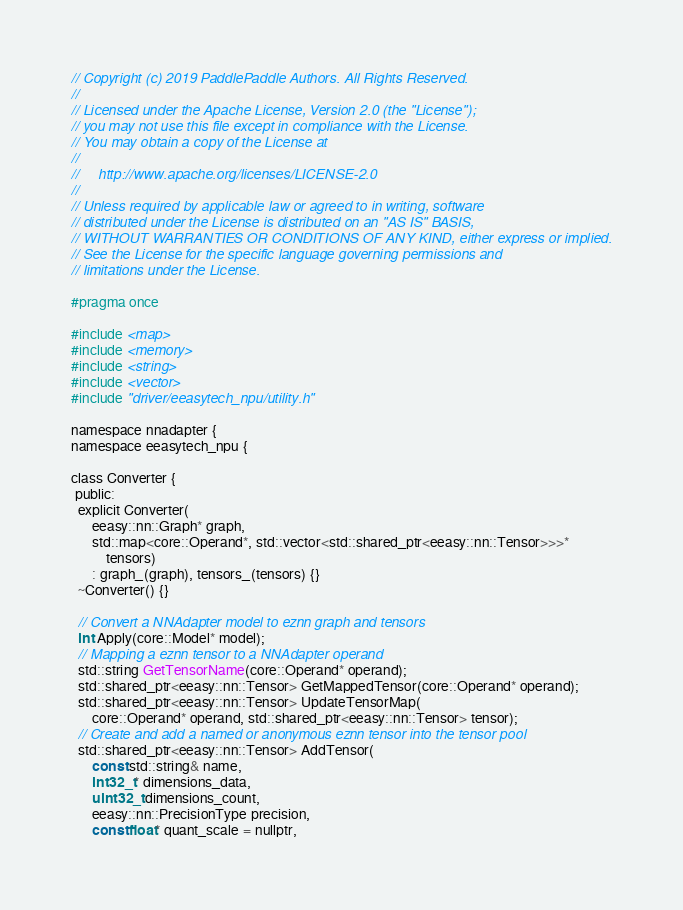Convert code to text. <code><loc_0><loc_0><loc_500><loc_500><_C_>// Copyright (c) 2019 PaddlePaddle Authors. All Rights Reserved.
//
// Licensed under the Apache License, Version 2.0 (the "License");
// you may not use this file except in compliance with the License.
// You may obtain a copy of the License at
//
//     http://www.apache.org/licenses/LICENSE-2.0
//
// Unless required by applicable law or agreed to in writing, software
// distributed under the License is distributed on an "AS IS" BASIS,
// WITHOUT WARRANTIES OR CONDITIONS OF ANY KIND, either express or implied.
// See the License for the specific language governing permissions and
// limitations under the License.

#pragma once

#include <map>
#include <memory>
#include <string>
#include <vector>
#include "driver/eeasytech_npu/utility.h"

namespace nnadapter {
namespace eeasytech_npu {

class Converter {
 public:
  explicit Converter(
      eeasy::nn::Graph* graph,
      std::map<core::Operand*, std::vector<std::shared_ptr<eeasy::nn::Tensor>>>*
          tensors)
      : graph_(graph), tensors_(tensors) {}
  ~Converter() {}

  // Convert a NNAdapter model to eznn graph and tensors
  int Apply(core::Model* model);
  // Mapping a eznn tensor to a NNAdapter operand
  std::string GetTensorName(core::Operand* operand);
  std::shared_ptr<eeasy::nn::Tensor> GetMappedTensor(core::Operand* operand);
  std::shared_ptr<eeasy::nn::Tensor> UpdateTensorMap(
      core::Operand* operand, std::shared_ptr<eeasy::nn::Tensor> tensor);
  // Create and add a named or anonymous eznn tensor into the tensor pool
  std::shared_ptr<eeasy::nn::Tensor> AddTensor(
      const std::string& name,
      int32_t* dimensions_data,
      uint32_t dimensions_count,
      eeasy::nn::PrecisionType precision,
      const float* quant_scale = nullptr,</code> 